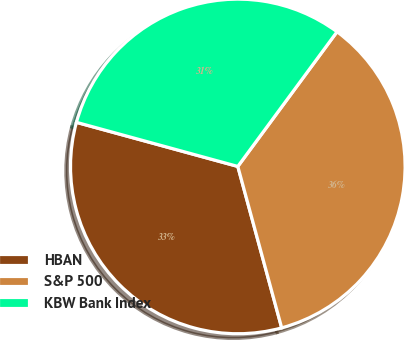Convert chart. <chart><loc_0><loc_0><loc_500><loc_500><pie_chart><fcel>HBAN<fcel>S&P 500<fcel>KBW Bank Index<nl><fcel>33.47%<fcel>35.67%<fcel>30.86%<nl></chart> 